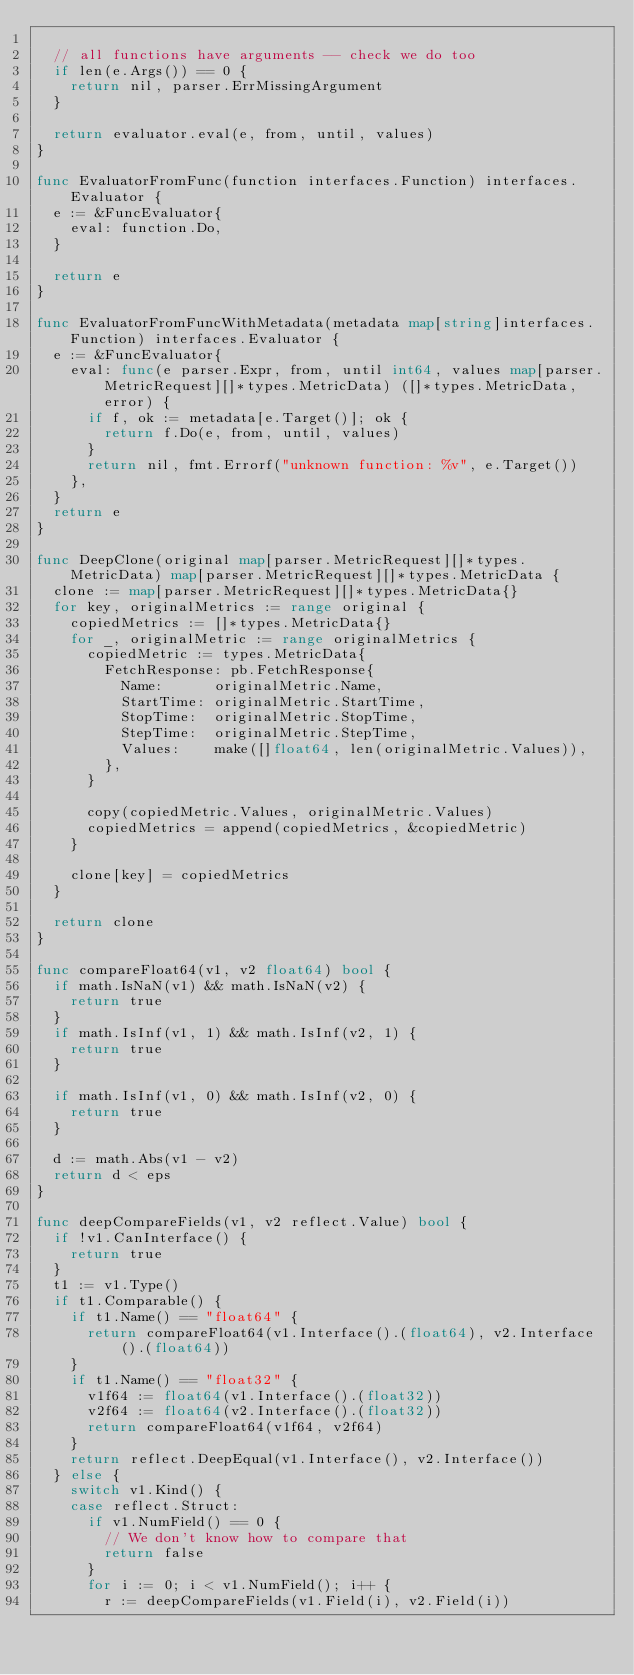Convert code to text. <code><loc_0><loc_0><loc_500><loc_500><_Go_>
	// all functions have arguments -- check we do too
	if len(e.Args()) == 0 {
		return nil, parser.ErrMissingArgument
	}

	return evaluator.eval(e, from, until, values)
}

func EvaluatorFromFunc(function interfaces.Function) interfaces.Evaluator {
	e := &FuncEvaluator{
		eval: function.Do,
	}

	return e
}

func EvaluatorFromFuncWithMetadata(metadata map[string]interfaces.Function) interfaces.Evaluator {
	e := &FuncEvaluator{
		eval: func(e parser.Expr, from, until int64, values map[parser.MetricRequest][]*types.MetricData) ([]*types.MetricData, error) {
			if f, ok := metadata[e.Target()]; ok {
				return f.Do(e, from, until, values)
			}
			return nil, fmt.Errorf("unknown function: %v", e.Target())
		},
	}
	return e
}

func DeepClone(original map[parser.MetricRequest][]*types.MetricData) map[parser.MetricRequest][]*types.MetricData {
	clone := map[parser.MetricRequest][]*types.MetricData{}
	for key, originalMetrics := range original {
		copiedMetrics := []*types.MetricData{}
		for _, originalMetric := range originalMetrics {
			copiedMetric := types.MetricData{
				FetchResponse: pb.FetchResponse{
					Name:      originalMetric.Name,
					StartTime: originalMetric.StartTime,
					StopTime:  originalMetric.StopTime,
					StepTime:  originalMetric.StepTime,
					Values:    make([]float64, len(originalMetric.Values)),
				},
			}

			copy(copiedMetric.Values, originalMetric.Values)
			copiedMetrics = append(copiedMetrics, &copiedMetric)
		}

		clone[key] = copiedMetrics
	}

	return clone
}

func compareFloat64(v1, v2 float64) bool {
	if math.IsNaN(v1) && math.IsNaN(v2) {
		return true
	}
	if math.IsInf(v1, 1) && math.IsInf(v2, 1) {
		return true
	}

	if math.IsInf(v1, 0) && math.IsInf(v2, 0) {
		return true
	}

	d := math.Abs(v1 - v2)
	return d < eps
}

func deepCompareFields(v1, v2 reflect.Value) bool {
	if !v1.CanInterface() {
		return true
	}
	t1 := v1.Type()
	if t1.Comparable() {
		if t1.Name() == "float64" {
			return compareFloat64(v1.Interface().(float64), v2.Interface().(float64))
		}
		if t1.Name() == "float32" {
			v1f64 := float64(v1.Interface().(float32))
			v2f64 := float64(v2.Interface().(float32))
			return compareFloat64(v1f64, v2f64)
		}
		return reflect.DeepEqual(v1.Interface(), v2.Interface())
	} else {
		switch v1.Kind() {
		case reflect.Struct:
			if v1.NumField() == 0 {
				// We don't know how to compare that
				return false
			}
			for i := 0; i < v1.NumField(); i++ {
				r := deepCompareFields(v1.Field(i), v2.Field(i))</code> 